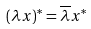Convert formula to latex. <formula><loc_0><loc_0><loc_500><loc_500>( \lambda x ) ^ { * } = \overline { \lambda } x ^ { * }</formula> 